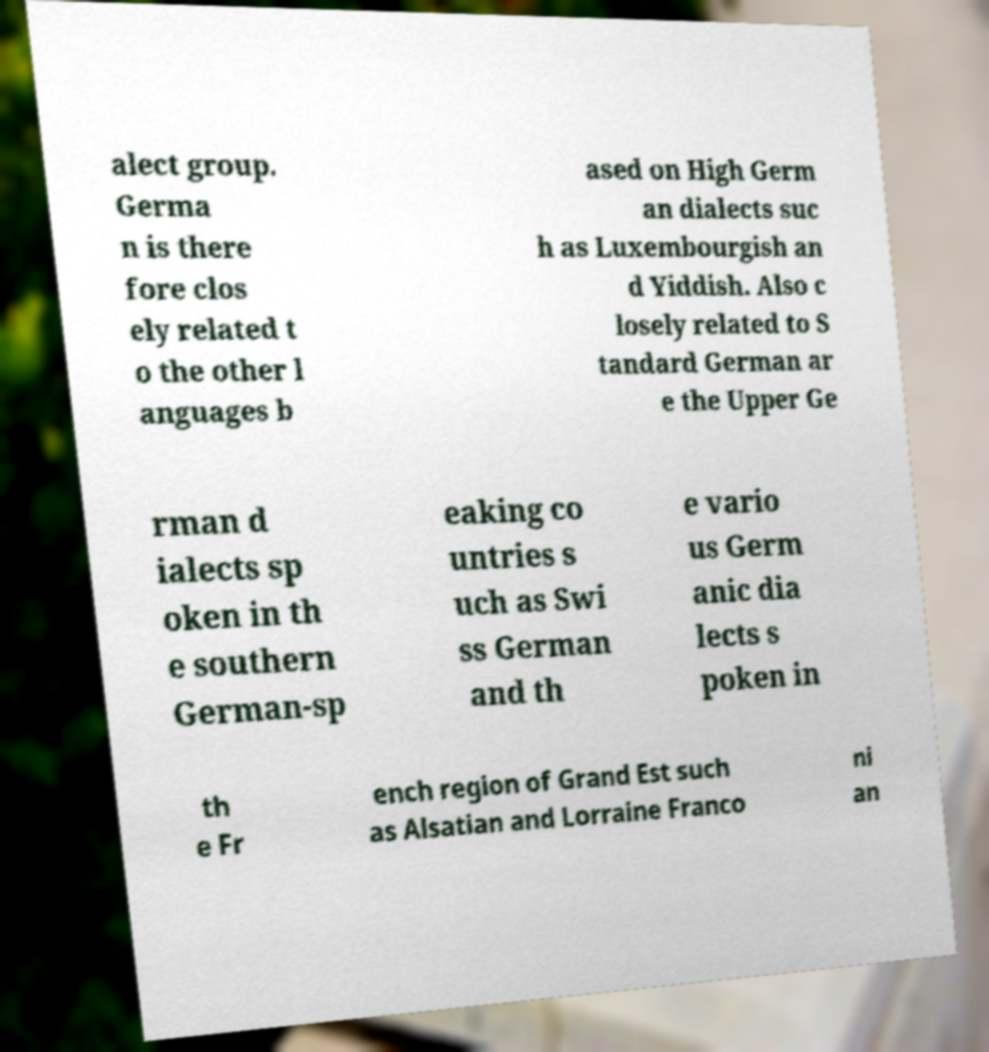What messages or text are displayed in this image? I need them in a readable, typed format. alect group. Germa n is there fore clos ely related t o the other l anguages b ased on High Germ an dialects suc h as Luxembourgish an d Yiddish. Also c losely related to S tandard German ar e the Upper Ge rman d ialects sp oken in th e southern German-sp eaking co untries s uch as Swi ss German and th e vario us Germ anic dia lects s poken in th e Fr ench region of Grand Est such as Alsatian and Lorraine Franco ni an 